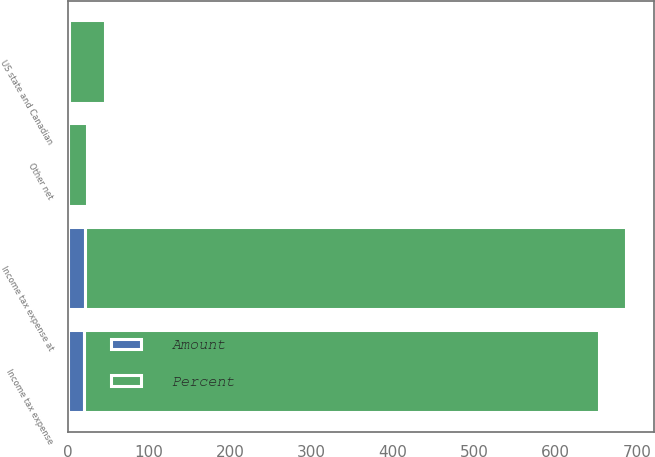Convert chart to OTSL. <chart><loc_0><loc_0><loc_500><loc_500><stacked_bar_chart><ecel><fcel>Income tax expense at<fcel>US state and Canadian<fcel>Other net<fcel>Income tax expense<nl><fcel>Percent<fcel>665<fcel>44<fcel>23<fcel>633<nl><fcel>Amount<fcel>21<fcel>1.4<fcel>0.7<fcel>20<nl></chart> 